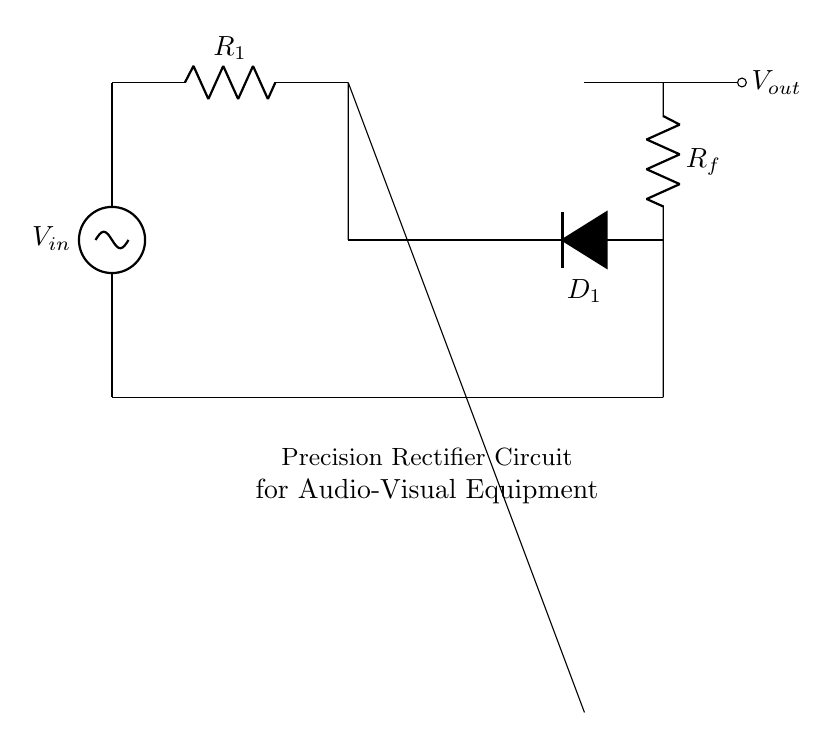What is the input voltage of the circuit? The input voltage, designated as V_in, is the voltage source connected to the top of the circuit. It indicates the signal level entering the precision rectifier.
Answer: V_in What are the two resistors present in the circuit? The circuit shows two resistors: R_1 and R_f. R_1 is placed in series with the input voltage, while R_f is in the feedback path of the operational amplifier.
Answer: R_1, R_f What type of components are used for rectification in this circuit? The circuit includes a diode symbol (D_1), which indicates that it uses a diode for the rectification process, specifically allowing current to pass in one direction.
Answer: Diode Why is an operational amplifier used in this rectifier circuit? The operational amplifier (op amp) functions to increase the accuracy and efficiency of the rectification process by allowing for a very precise output voltage that follows the input signal, facilitating signal processing in audio-visual applications.
Answer: To increase accuracy What is the purpose of R_f in the circuit? R_f serves as the feedback resistor in the operational amplifier configuration, which sets the gain of the circuit and influences the output voltage's behavior in response to the input signal, ensuring precise rectification.
Answer: Sets gain What is the output voltage of this rectifier circuit? The output voltage, represented as V_out, reflects the processed signal after rectification; in ideal conditions, it follows V_in during the positive half-cycle and is zero during the negative, indicating unidirectional current flow.
Answer: V_out 